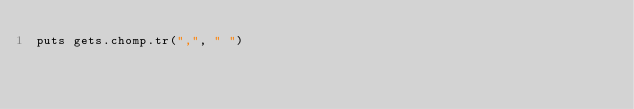Convert code to text. <code><loc_0><loc_0><loc_500><loc_500><_Ruby_>puts gets.chomp.tr(",", " ")
</code> 